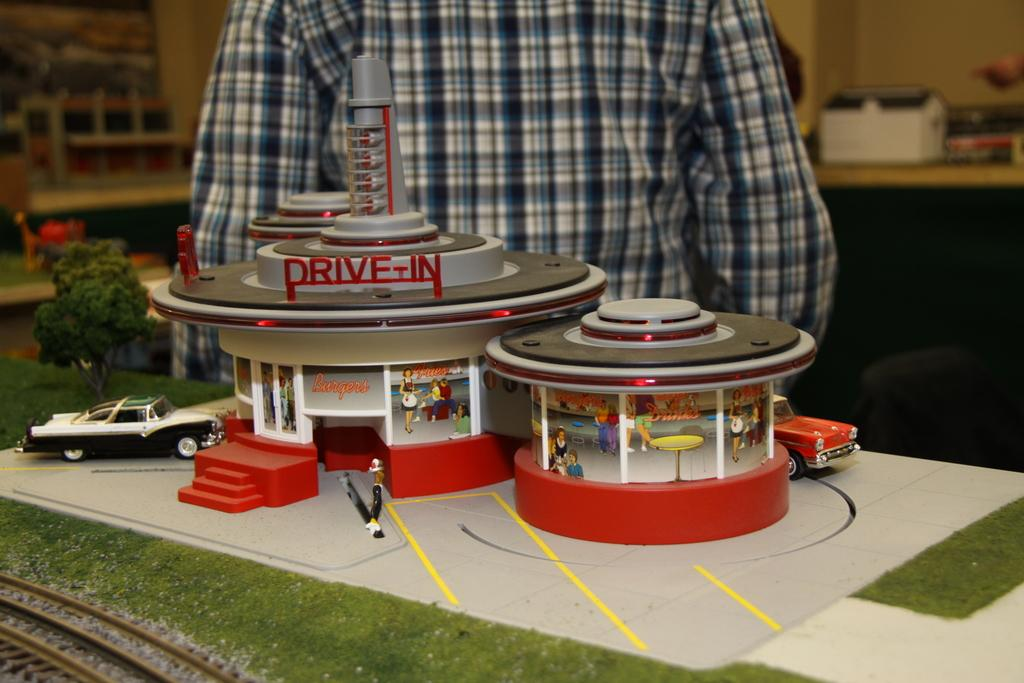Provide a one-sentence caption for the provided image. A children's toy that is part of a railroad set that has a drive-in. 